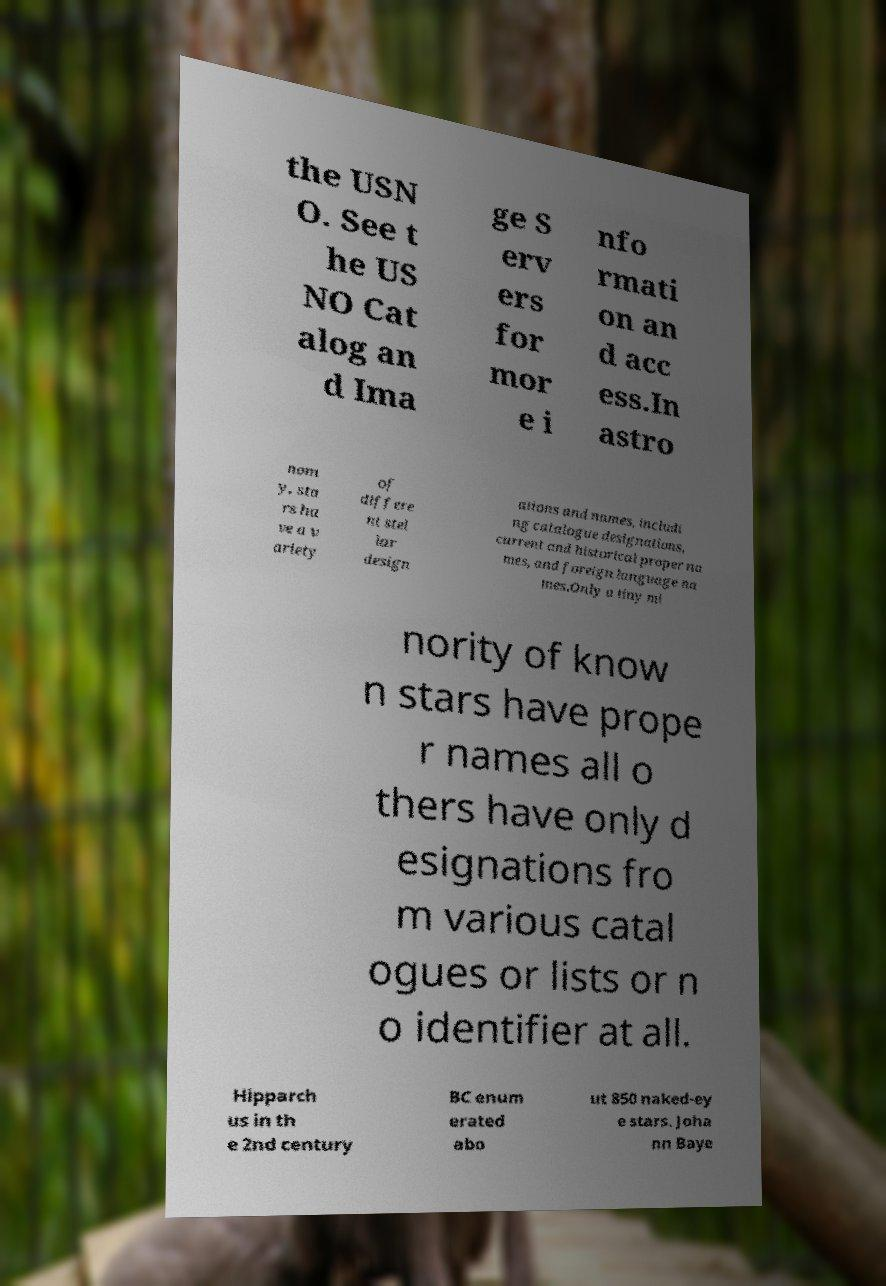Please identify and transcribe the text found in this image. the USN O. See t he US NO Cat alog an d Ima ge S erv ers for mor e i nfo rmati on an d acc ess.In astro nom y, sta rs ha ve a v ariety of differe nt stel lar design ations and names, includi ng catalogue designations, current and historical proper na mes, and foreign language na mes.Only a tiny mi nority of know n stars have prope r names all o thers have only d esignations fro m various catal ogues or lists or n o identifier at all. Hipparch us in th e 2nd century BC enum erated abo ut 850 naked-ey e stars. Joha nn Baye 